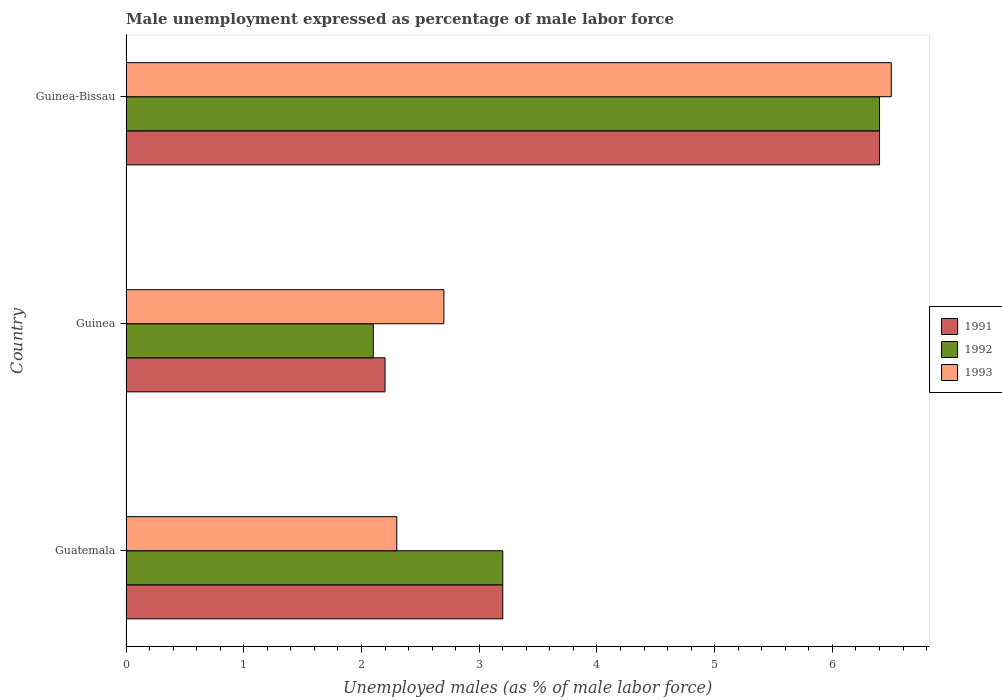How many different coloured bars are there?
Keep it short and to the point. 3. How many bars are there on the 2nd tick from the top?
Give a very brief answer. 3. How many bars are there on the 1st tick from the bottom?
Make the answer very short. 3. What is the label of the 1st group of bars from the top?
Offer a terse response. Guinea-Bissau. In how many cases, is the number of bars for a given country not equal to the number of legend labels?
Your response must be concise. 0. What is the unemployment in males in in 1991 in Guinea?
Make the answer very short. 2.2. Across all countries, what is the maximum unemployment in males in in 1991?
Your answer should be compact. 6.4. Across all countries, what is the minimum unemployment in males in in 1992?
Make the answer very short. 2.1. In which country was the unemployment in males in in 1992 maximum?
Your answer should be compact. Guinea-Bissau. In which country was the unemployment in males in in 1993 minimum?
Offer a terse response. Guatemala. What is the total unemployment in males in in 1992 in the graph?
Make the answer very short. 11.7. What is the difference between the unemployment in males in in 1992 in Guinea-Bissau and the unemployment in males in in 1993 in Guinea?
Give a very brief answer. 3.7. What is the average unemployment in males in in 1993 per country?
Make the answer very short. 3.83. What is the difference between the unemployment in males in in 1993 and unemployment in males in in 1992 in Guinea?
Offer a very short reply. 0.6. In how many countries, is the unemployment in males in in 1991 greater than 1.6 %?
Your response must be concise. 3. What is the ratio of the unemployment in males in in 1993 in Guinea to that in Guinea-Bissau?
Make the answer very short. 0.42. Is the unemployment in males in in 1992 in Guatemala less than that in Guinea?
Provide a succinct answer. No. Is the difference between the unemployment in males in in 1993 in Guinea and Guinea-Bissau greater than the difference between the unemployment in males in in 1992 in Guinea and Guinea-Bissau?
Your answer should be compact. Yes. What is the difference between the highest and the second highest unemployment in males in in 1993?
Offer a terse response. 3.8. What is the difference between the highest and the lowest unemployment in males in in 1992?
Ensure brevity in your answer.  4.3. In how many countries, is the unemployment in males in in 1993 greater than the average unemployment in males in in 1993 taken over all countries?
Provide a short and direct response. 1. How many countries are there in the graph?
Make the answer very short. 3. What is the difference between two consecutive major ticks on the X-axis?
Make the answer very short. 1. Where does the legend appear in the graph?
Make the answer very short. Center right. What is the title of the graph?
Your answer should be very brief. Male unemployment expressed as percentage of male labor force. What is the label or title of the X-axis?
Your response must be concise. Unemployed males (as % of male labor force). What is the Unemployed males (as % of male labor force) of 1991 in Guatemala?
Keep it short and to the point. 3.2. What is the Unemployed males (as % of male labor force) in 1992 in Guatemala?
Give a very brief answer. 3.2. What is the Unemployed males (as % of male labor force) in 1993 in Guatemala?
Provide a succinct answer. 2.3. What is the Unemployed males (as % of male labor force) of 1991 in Guinea?
Provide a short and direct response. 2.2. What is the Unemployed males (as % of male labor force) in 1992 in Guinea?
Your response must be concise. 2.1. What is the Unemployed males (as % of male labor force) in 1993 in Guinea?
Provide a succinct answer. 2.7. What is the Unemployed males (as % of male labor force) in 1991 in Guinea-Bissau?
Offer a very short reply. 6.4. What is the Unemployed males (as % of male labor force) of 1992 in Guinea-Bissau?
Keep it short and to the point. 6.4. Across all countries, what is the maximum Unemployed males (as % of male labor force) in 1991?
Offer a very short reply. 6.4. Across all countries, what is the maximum Unemployed males (as % of male labor force) of 1992?
Your answer should be compact. 6.4. Across all countries, what is the maximum Unemployed males (as % of male labor force) in 1993?
Give a very brief answer. 6.5. Across all countries, what is the minimum Unemployed males (as % of male labor force) of 1991?
Your answer should be compact. 2.2. Across all countries, what is the minimum Unemployed males (as % of male labor force) of 1992?
Your answer should be very brief. 2.1. Across all countries, what is the minimum Unemployed males (as % of male labor force) of 1993?
Keep it short and to the point. 2.3. What is the total Unemployed males (as % of male labor force) of 1991 in the graph?
Give a very brief answer. 11.8. What is the difference between the Unemployed males (as % of male labor force) of 1991 in Guatemala and that in Guinea?
Keep it short and to the point. 1. What is the difference between the Unemployed males (as % of male labor force) in 1992 in Guatemala and that in Guinea?
Your answer should be compact. 1.1. What is the difference between the Unemployed males (as % of male labor force) in 1993 in Guatemala and that in Guinea?
Offer a very short reply. -0.4. What is the difference between the Unemployed males (as % of male labor force) of 1991 in Guatemala and that in Guinea-Bissau?
Give a very brief answer. -3.2. What is the difference between the Unemployed males (as % of male labor force) of 1992 in Guatemala and that in Guinea-Bissau?
Provide a succinct answer. -3.2. What is the difference between the Unemployed males (as % of male labor force) in 1993 in Guatemala and that in Guinea-Bissau?
Offer a very short reply. -4.2. What is the difference between the Unemployed males (as % of male labor force) of 1991 in Guinea and that in Guinea-Bissau?
Offer a terse response. -4.2. What is the difference between the Unemployed males (as % of male labor force) in 1993 in Guinea and that in Guinea-Bissau?
Provide a succinct answer. -3.8. What is the difference between the Unemployed males (as % of male labor force) in 1992 in Guatemala and the Unemployed males (as % of male labor force) in 1993 in Guinea?
Offer a very short reply. 0.5. What is the difference between the Unemployed males (as % of male labor force) in 1992 in Guatemala and the Unemployed males (as % of male labor force) in 1993 in Guinea-Bissau?
Your answer should be very brief. -3.3. What is the difference between the Unemployed males (as % of male labor force) of 1991 in Guinea and the Unemployed males (as % of male labor force) of 1992 in Guinea-Bissau?
Provide a succinct answer. -4.2. What is the difference between the Unemployed males (as % of male labor force) of 1992 in Guinea and the Unemployed males (as % of male labor force) of 1993 in Guinea-Bissau?
Keep it short and to the point. -4.4. What is the average Unemployed males (as % of male labor force) of 1991 per country?
Offer a terse response. 3.93. What is the average Unemployed males (as % of male labor force) of 1992 per country?
Your answer should be very brief. 3.9. What is the average Unemployed males (as % of male labor force) in 1993 per country?
Your answer should be very brief. 3.83. What is the difference between the Unemployed males (as % of male labor force) in 1991 and Unemployed males (as % of male labor force) in 1992 in Guinea?
Your answer should be compact. 0.1. What is the difference between the Unemployed males (as % of male labor force) of 1992 and Unemployed males (as % of male labor force) of 1993 in Guinea?
Keep it short and to the point. -0.6. What is the difference between the Unemployed males (as % of male labor force) of 1991 and Unemployed males (as % of male labor force) of 1993 in Guinea-Bissau?
Provide a succinct answer. -0.1. What is the difference between the Unemployed males (as % of male labor force) in 1992 and Unemployed males (as % of male labor force) in 1993 in Guinea-Bissau?
Your answer should be very brief. -0.1. What is the ratio of the Unemployed males (as % of male labor force) in 1991 in Guatemala to that in Guinea?
Offer a terse response. 1.45. What is the ratio of the Unemployed males (as % of male labor force) in 1992 in Guatemala to that in Guinea?
Ensure brevity in your answer.  1.52. What is the ratio of the Unemployed males (as % of male labor force) in 1993 in Guatemala to that in Guinea?
Ensure brevity in your answer.  0.85. What is the ratio of the Unemployed males (as % of male labor force) in 1992 in Guatemala to that in Guinea-Bissau?
Your answer should be very brief. 0.5. What is the ratio of the Unemployed males (as % of male labor force) of 1993 in Guatemala to that in Guinea-Bissau?
Provide a succinct answer. 0.35. What is the ratio of the Unemployed males (as % of male labor force) of 1991 in Guinea to that in Guinea-Bissau?
Offer a very short reply. 0.34. What is the ratio of the Unemployed males (as % of male labor force) of 1992 in Guinea to that in Guinea-Bissau?
Give a very brief answer. 0.33. What is the ratio of the Unemployed males (as % of male labor force) in 1993 in Guinea to that in Guinea-Bissau?
Your answer should be compact. 0.42. What is the difference between the highest and the second highest Unemployed males (as % of male labor force) in 1991?
Your answer should be very brief. 3.2. What is the difference between the highest and the second highest Unemployed males (as % of male labor force) of 1992?
Keep it short and to the point. 3.2. What is the difference between the highest and the second highest Unemployed males (as % of male labor force) in 1993?
Provide a short and direct response. 3.8. What is the difference between the highest and the lowest Unemployed males (as % of male labor force) of 1991?
Ensure brevity in your answer.  4.2. What is the difference between the highest and the lowest Unemployed males (as % of male labor force) in 1993?
Your answer should be very brief. 4.2. 